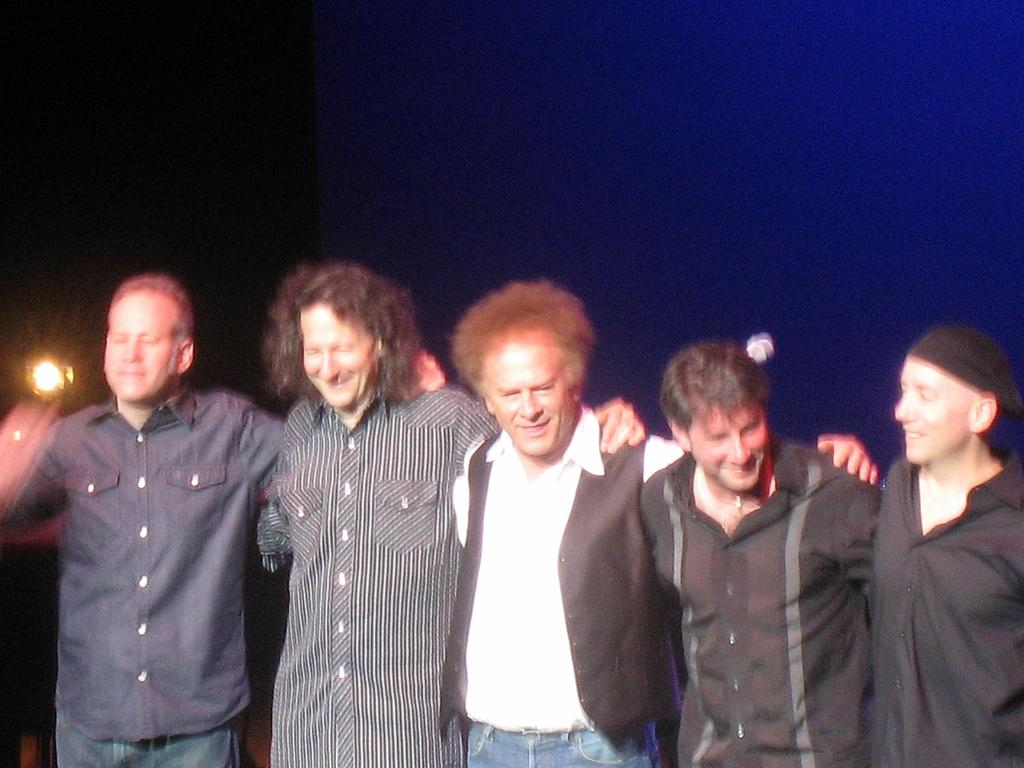How many people are in the image? There are persons in the image, but the exact number is not specified. What can be seen in the background of the image? There is a light in the background of the image. What type of scarf is the person wearing in the image? There is no mention of a scarf or a person wearing a scarf in the image. What is the size of the person in the image? The size of the person(s) in the image is not specified in the facts provided. 